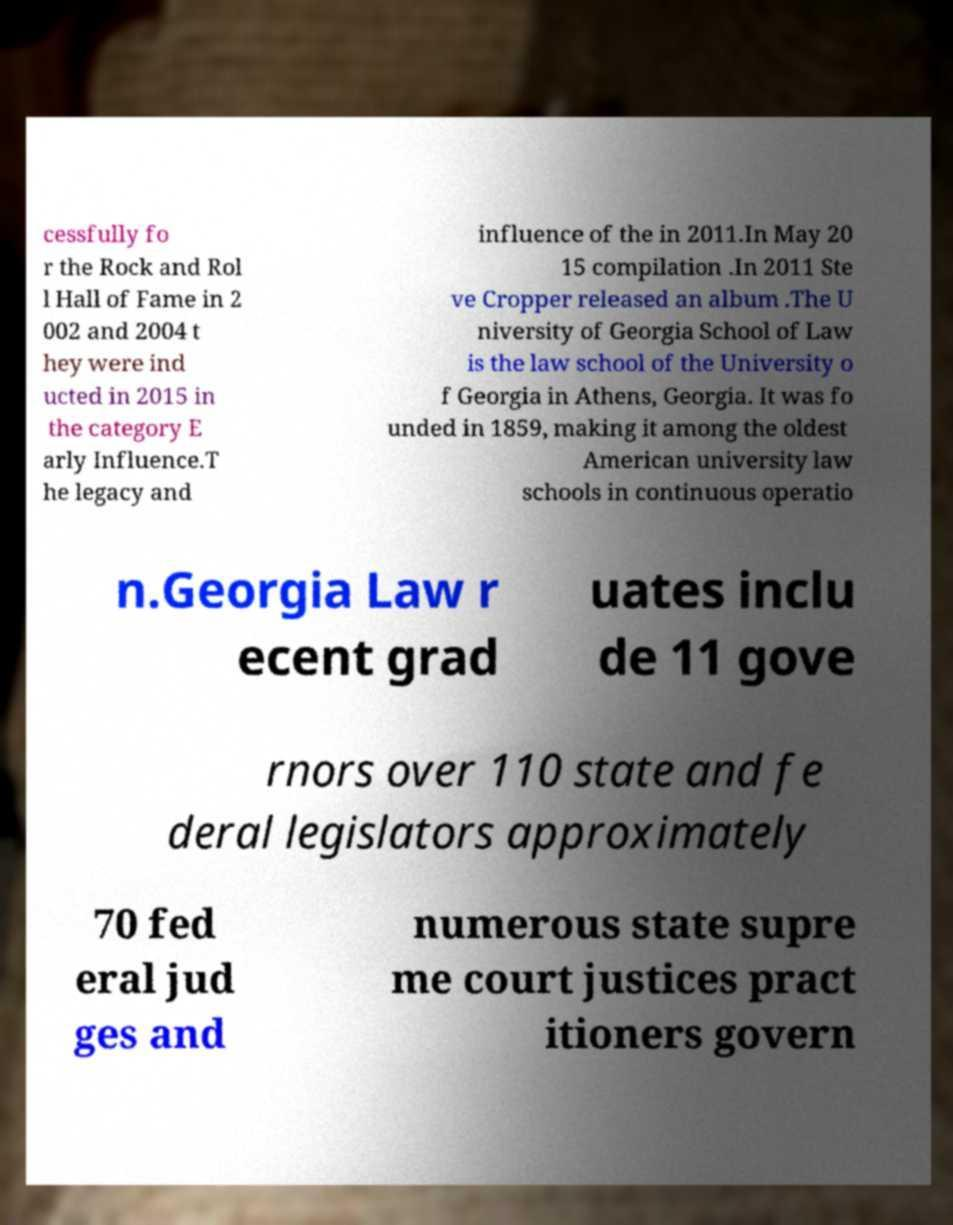What messages or text are displayed in this image? I need them in a readable, typed format. cessfully fo r the Rock and Rol l Hall of Fame in 2 002 and 2004 t hey were ind ucted in 2015 in the category E arly Influence.T he legacy and influence of the in 2011.In May 20 15 compilation .In 2011 Ste ve Cropper released an album .The U niversity of Georgia School of Law is the law school of the University o f Georgia in Athens, Georgia. It was fo unded in 1859, making it among the oldest American university law schools in continuous operatio n.Georgia Law r ecent grad uates inclu de 11 gove rnors over 110 state and fe deral legislators approximately 70 fed eral jud ges and numerous state supre me court justices pract itioners govern 